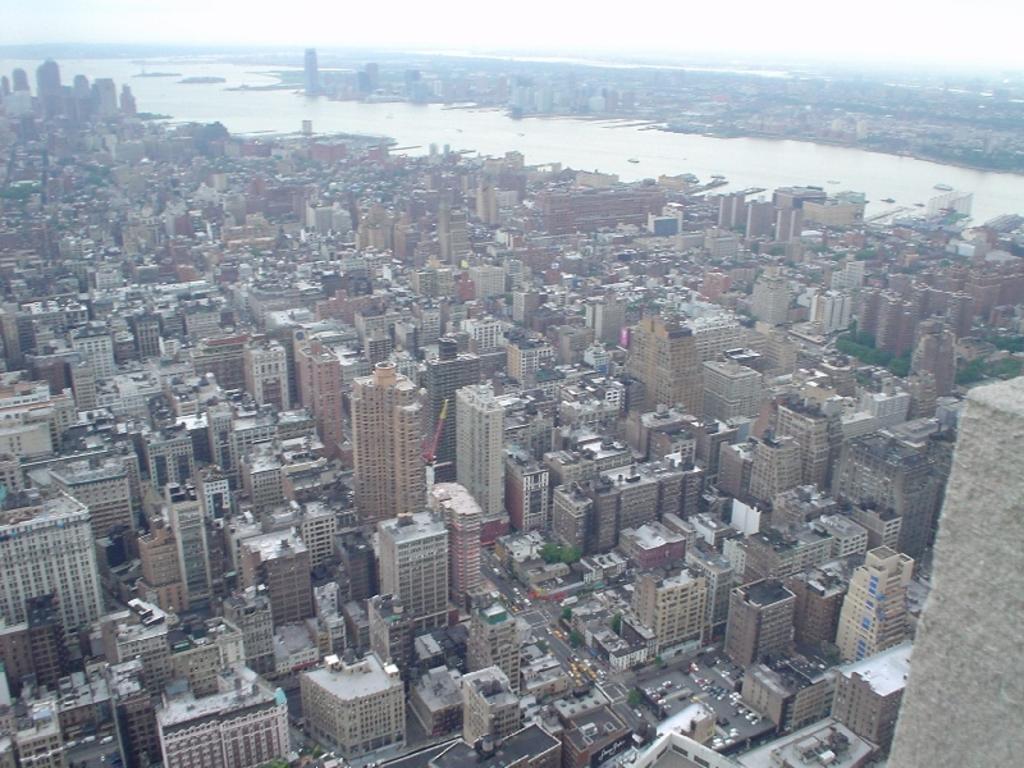Describe this image in one or two sentences. In this image we can see many buildings and skyscrapers. There are few roads in the image. There are many vehicles in the image. There is a river in the image. There are many trees in the image. There is a sky in the image. 